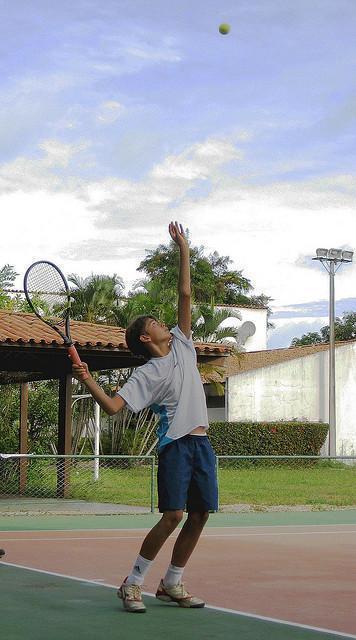Why is he standing like that?
Make your selection and explain in format: 'Answer: answer
Rationale: rationale.'
Options: Ball coming, is fighting, is afraid, is falling. Answer: ball coming.
Rationale: The person is waiting for something to fall to him so he can hit it with a racquet. option a matches the item and its action. 